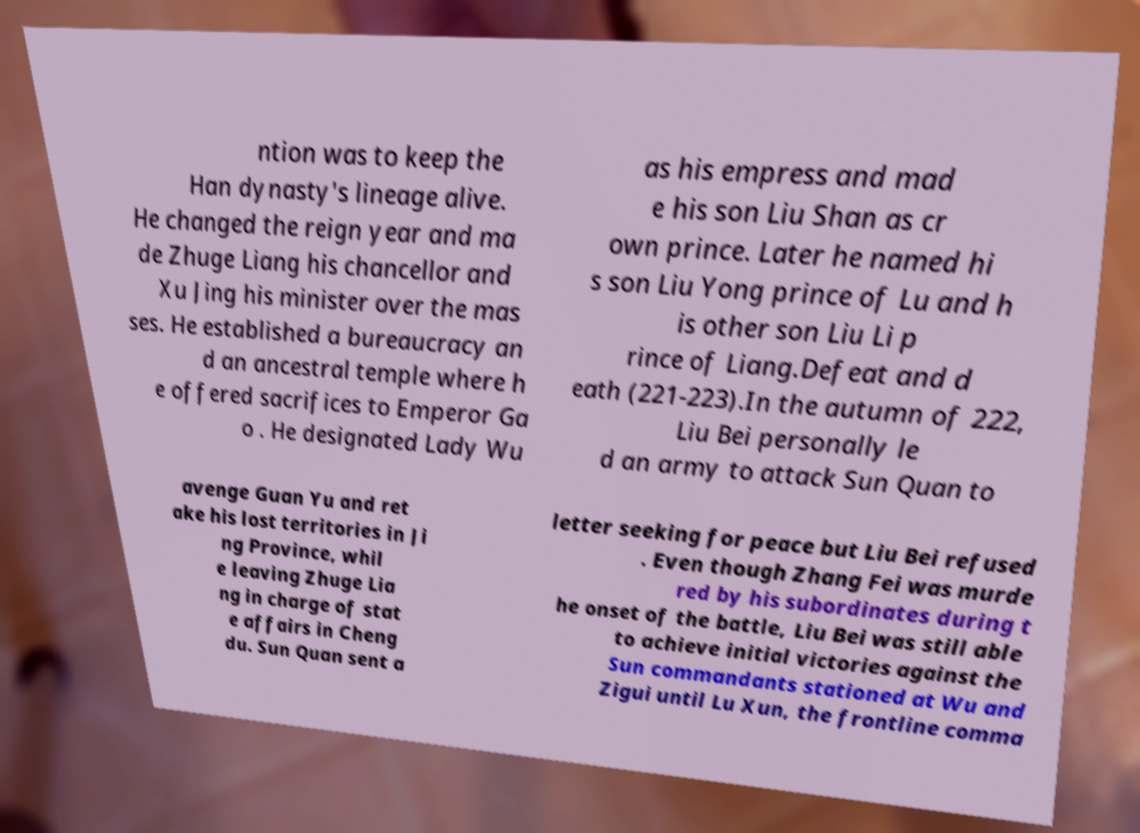Please identify and transcribe the text found in this image. ntion was to keep the Han dynasty's lineage alive. He changed the reign year and ma de Zhuge Liang his chancellor and Xu Jing his minister over the mas ses. He established a bureaucracy an d an ancestral temple where h e offered sacrifices to Emperor Ga o . He designated Lady Wu as his empress and mad e his son Liu Shan as cr own prince. Later he named hi s son Liu Yong prince of Lu and h is other son Liu Li p rince of Liang.Defeat and d eath (221-223).In the autumn of 222, Liu Bei personally le d an army to attack Sun Quan to avenge Guan Yu and ret ake his lost territories in Ji ng Province, whil e leaving Zhuge Lia ng in charge of stat e affairs in Cheng du. Sun Quan sent a letter seeking for peace but Liu Bei refused . Even though Zhang Fei was murde red by his subordinates during t he onset of the battle, Liu Bei was still able to achieve initial victories against the Sun commandants stationed at Wu and Zigui until Lu Xun, the frontline comma 